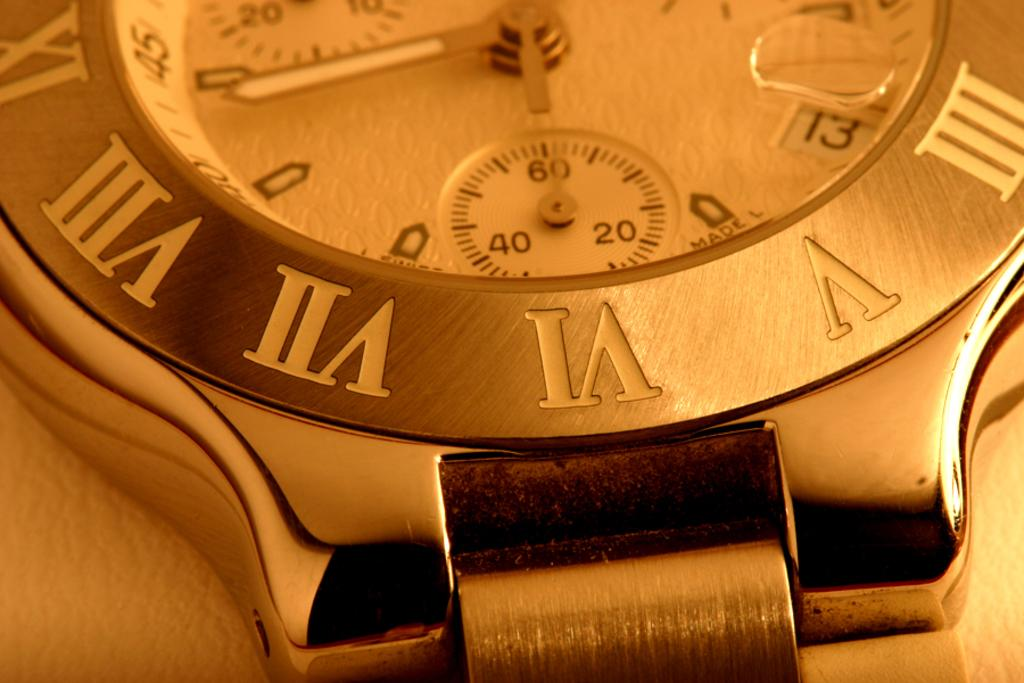<image>
Create a compact narrative representing the image presented. Roman numeral silver watch which contains a compass 